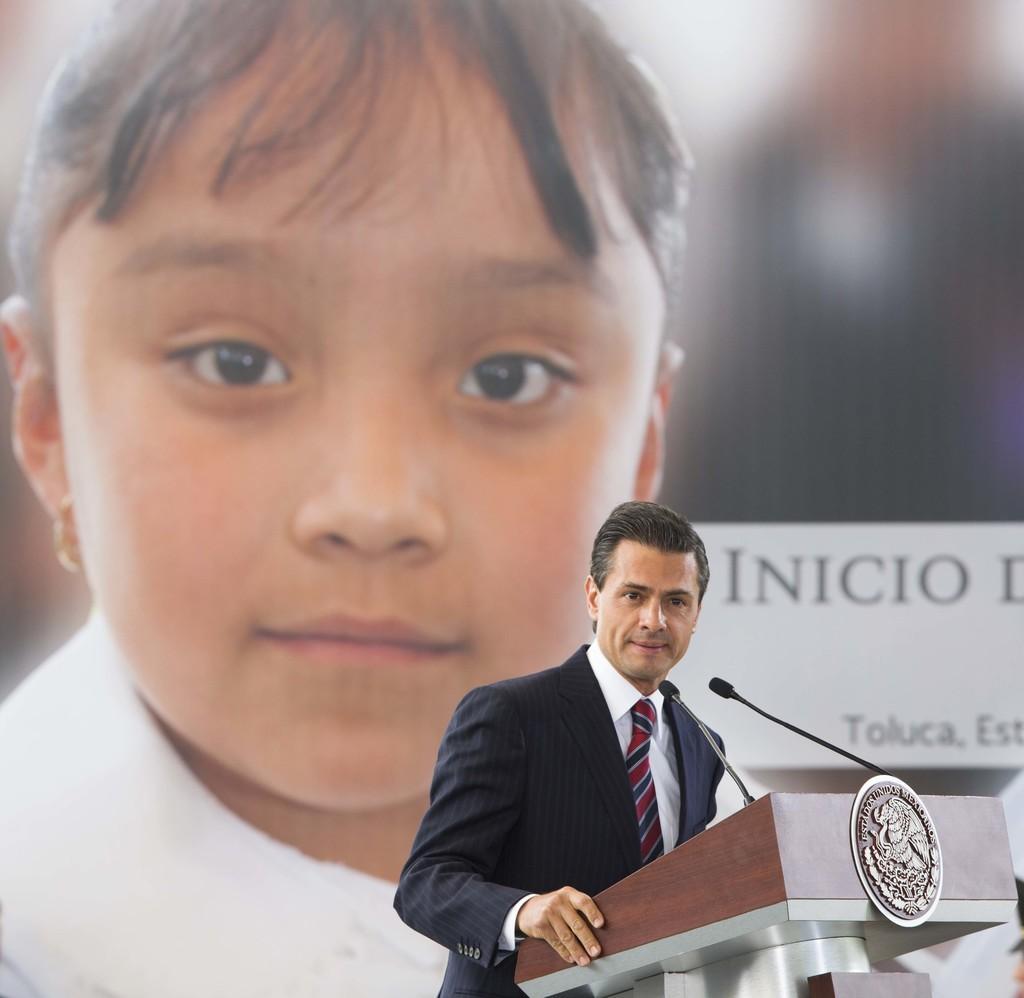Can you describe this image briefly? This is the man standing. I can see a podium with the two mikes and a logo attached to it. This man wore a suit, shirt and tie. In the background, that looks like a banner with the picture of a girl. 